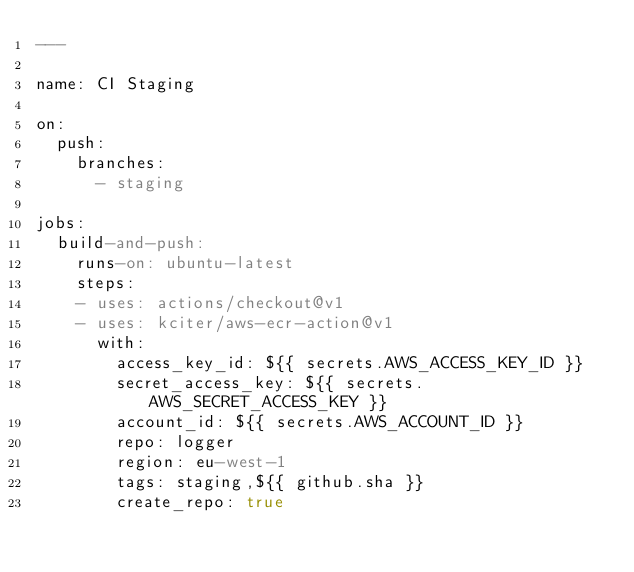<code> <loc_0><loc_0><loc_500><loc_500><_YAML_>---

name: CI Staging

on:
  push:
    branches:
      - staging

jobs:
  build-and-push:
    runs-on: ubuntu-latest
    steps:
    - uses: actions/checkout@v1
    - uses: kciter/aws-ecr-action@v1
      with:
        access_key_id: ${{ secrets.AWS_ACCESS_KEY_ID }}
        secret_access_key: ${{ secrets.AWS_SECRET_ACCESS_KEY }}
        account_id: ${{ secrets.AWS_ACCOUNT_ID }}
        repo: logger
        region: eu-west-1
        tags: staging,${{ github.sha }}
        create_repo: true
</code> 